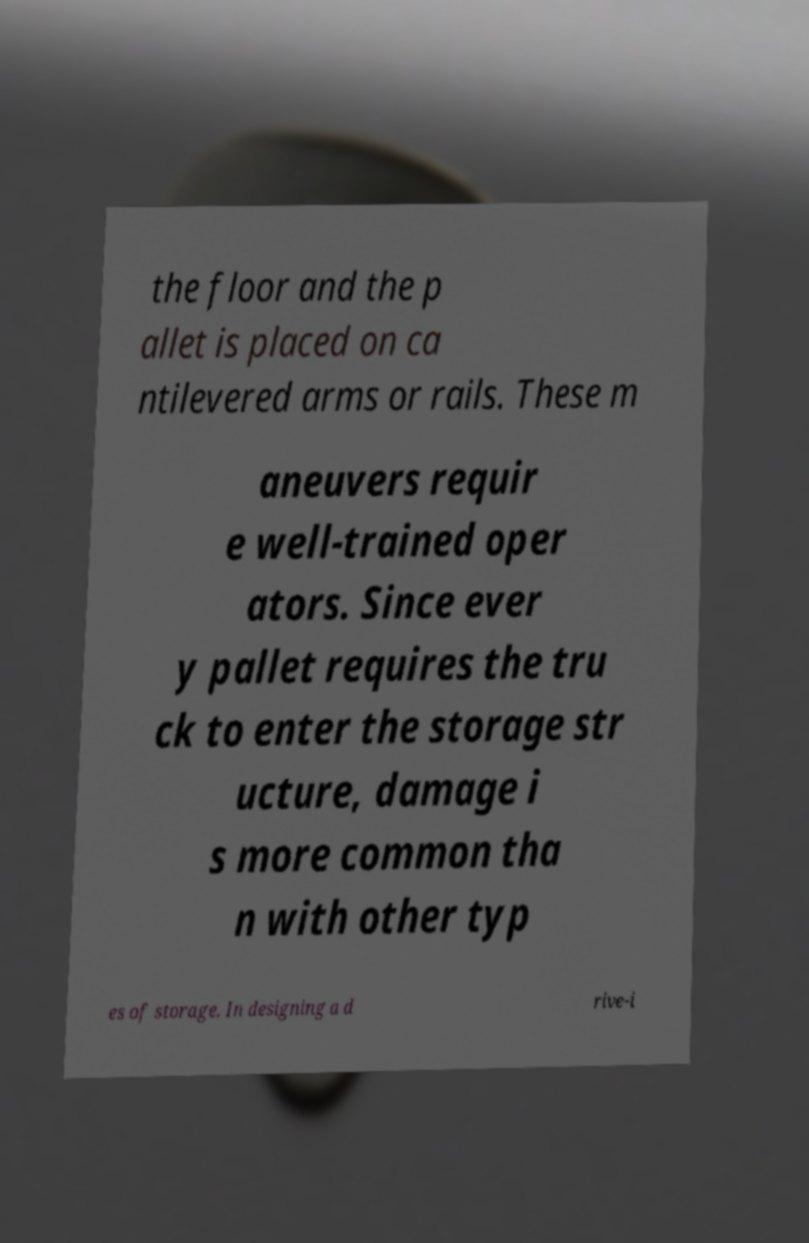Please read and relay the text visible in this image. What does it say? the floor and the p allet is placed on ca ntilevered arms or rails. These m aneuvers requir e well-trained oper ators. Since ever y pallet requires the tru ck to enter the storage str ucture, damage i s more common tha n with other typ es of storage. In designing a d rive-i 